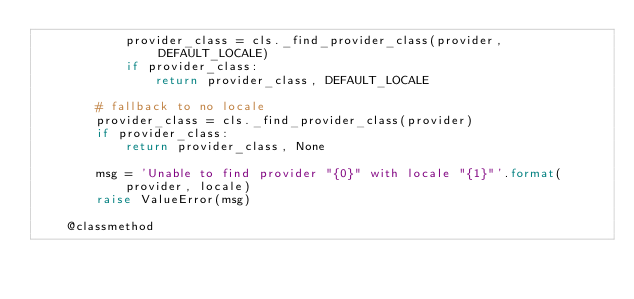Convert code to text. <code><loc_0><loc_0><loc_500><loc_500><_Python_>            provider_class = cls._find_provider_class(provider, DEFAULT_LOCALE)
            if provider_class:
                return provider_class, DEFAULT_LOCALE

        # fallback to no locale
        provider_class = cls._find_provider_class(provider)
        if provider_class:
            return provider_class, None

        msg = 'Unable to find provider "{0}" with locale "{1}"'.format(
            provider, locale)
        raise ValueError(msg)

    @classmethod</code> 